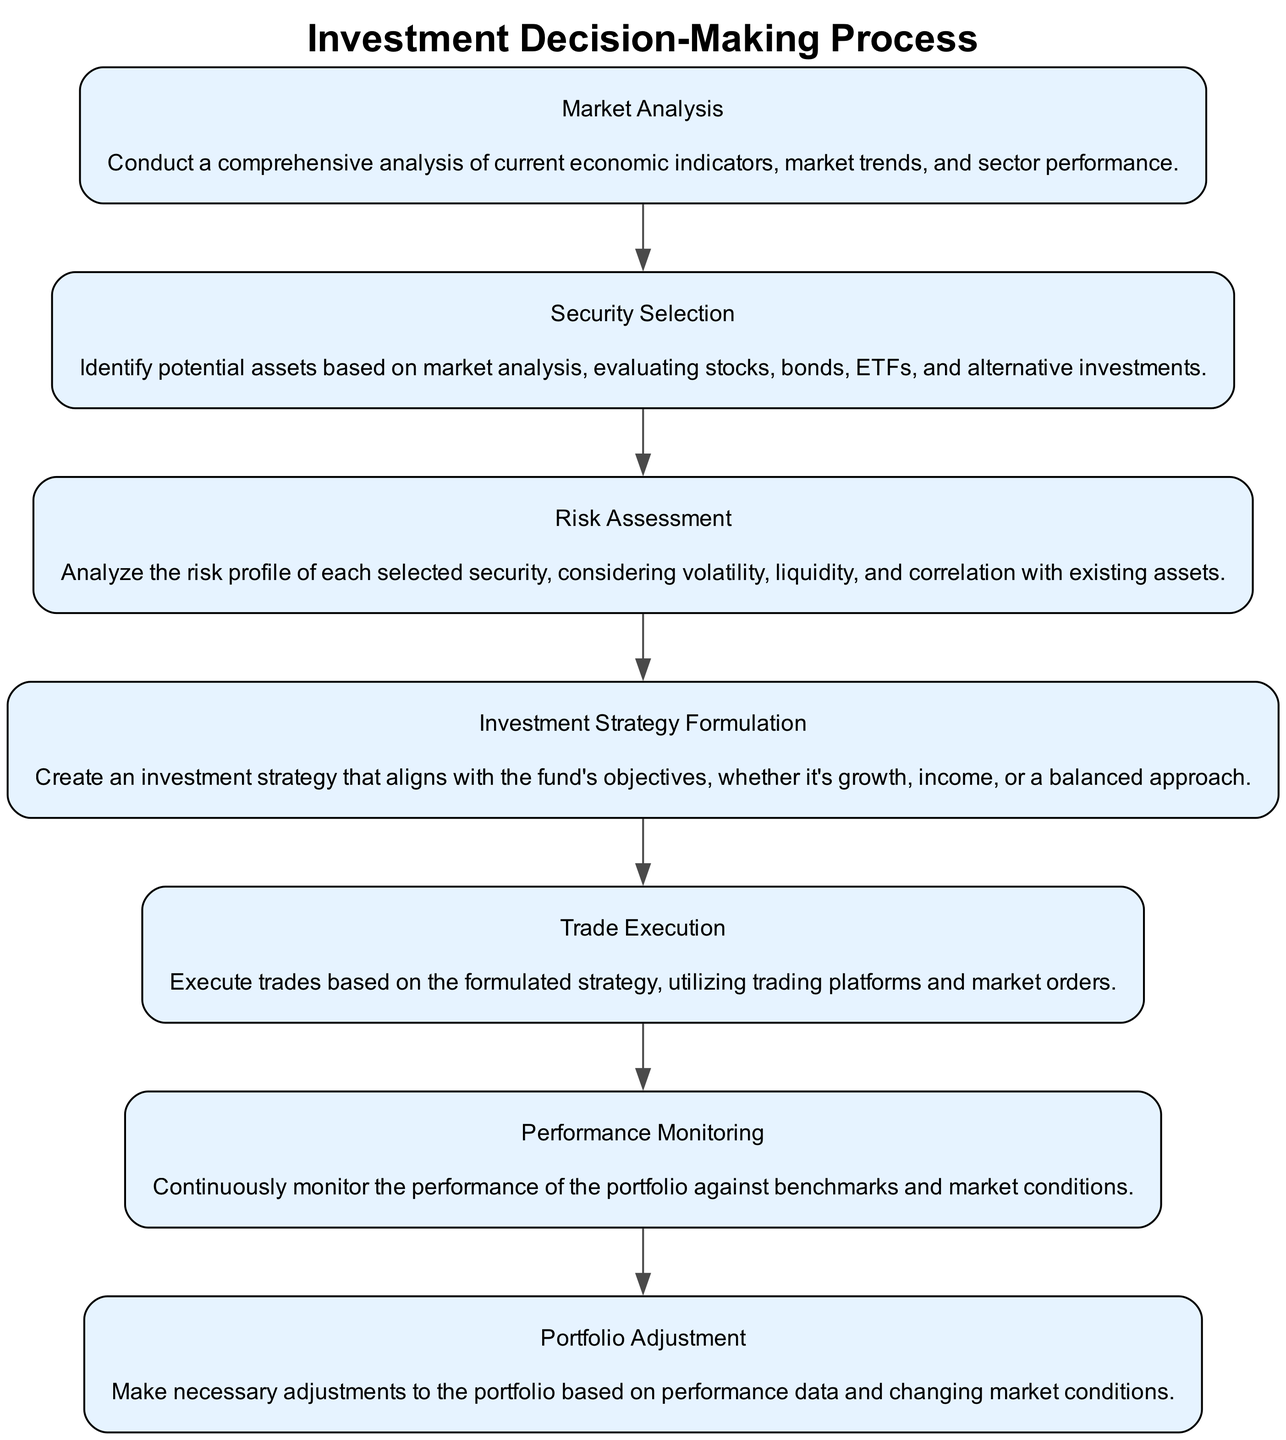What is the first step in the diagram? The first step is "Market Analysis," which is explicitly listed as the initial node of the process.
Answer: Market Analysis How many steps are outlined in the investment decision-making process? There are a total of 7 steps detailed in the diagram, as counted from "Market Analysis" to "Portfolio Adjustment."
Answer: 7 What follows after "Risk Assessment"? The step that comes after "Risk Assessment" is "Investment Strategy Formulation," which directly connects as the next node in the flow.
Answer: Investment Strategy Formulation What is the focus of the "Trade Execution" step? "Trade Execution" focuses on executing trades based on the formulated strategy, as stated in its description.
Answer: Executing trades Which step includes continuous monitoring of portfolio performance? "Performance Monitoring" is the step that involves continuously monitoring the portfolio's performance, according to its description.
Answer: Performance Monitoring How do you perform adjustments in your portfolio according to the diagram? Adjustments to the portfolio are made in the "Portfolio Adjustment" step, based on performance data and market conditions.
Answer: Portfolio Adjustment What is the relationship between "Security Selection" and "Risk Assessment"? "Security Selection" occurs directly before "Risk Assessment," indicating that potential assets are evaluated prior to conducting any risk analysis.
Answer: Sequential relationship Which step involves creating an investment strategy? The step that involves creating an investment strategy is "Investment Strategy Formulation," as clearly stated in the diagram.
Answer: Investment Strategy Formulation What type of analysis is conducted in the "Market Analysis" step? A comprehensive analysis of current economic indicators, market trends, and sector performance is conducted in this step.
Answer: Comprehensive analysis 